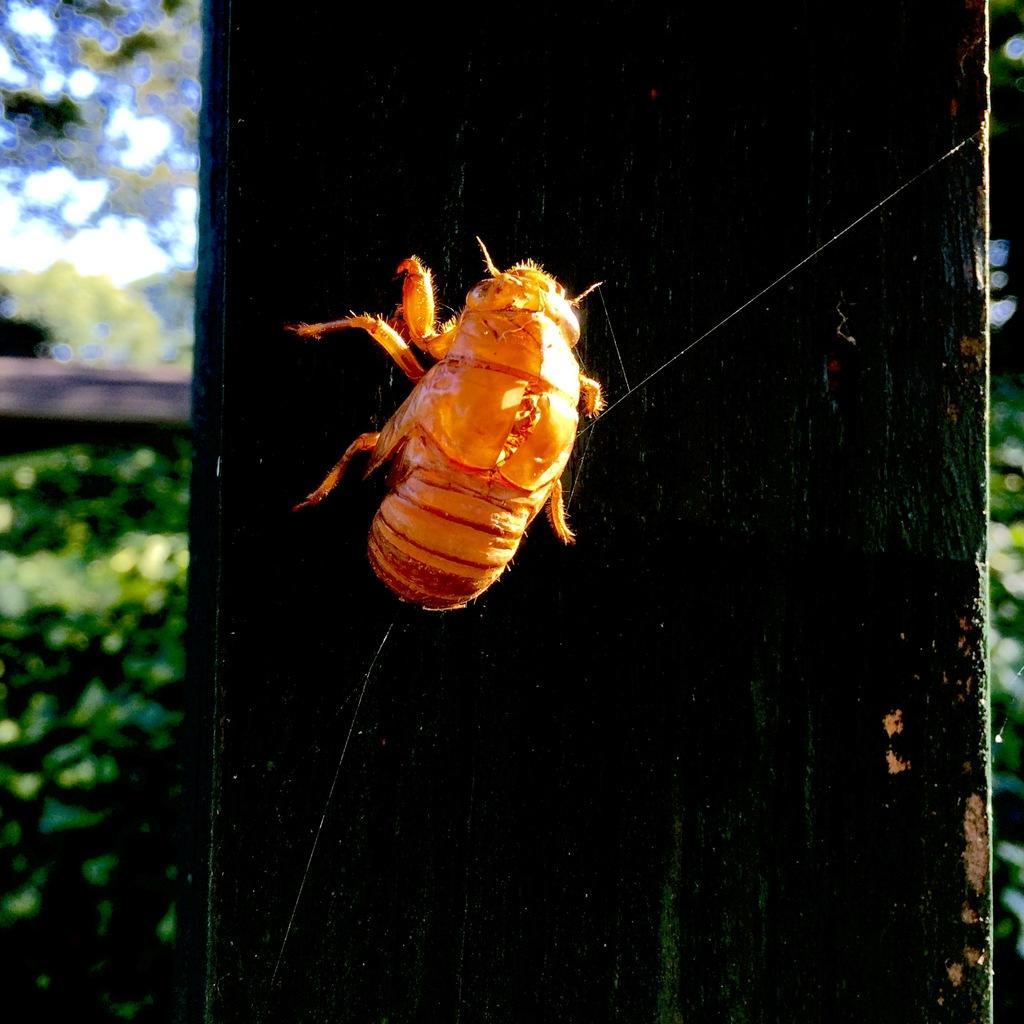Could you give a brief overview of what you see in this image? In this picture we can see a wooden pillar in the front, there is an insect on the pillar, in the background we can see some plants, there is a blurry background. 